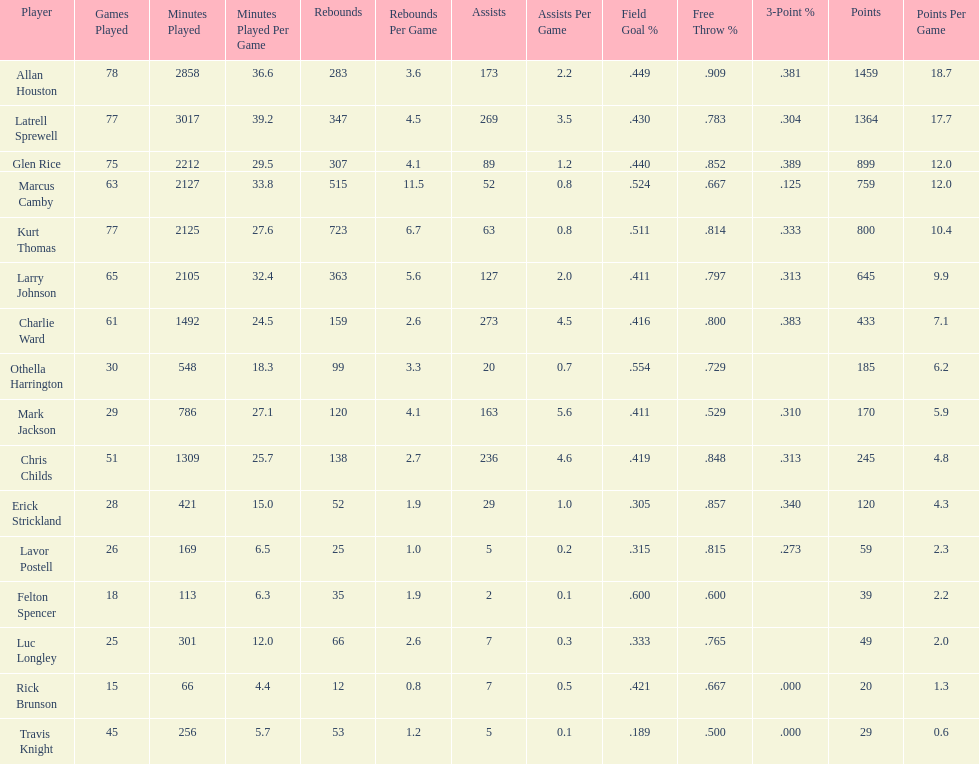Give the number of players covered by the table. 16. 